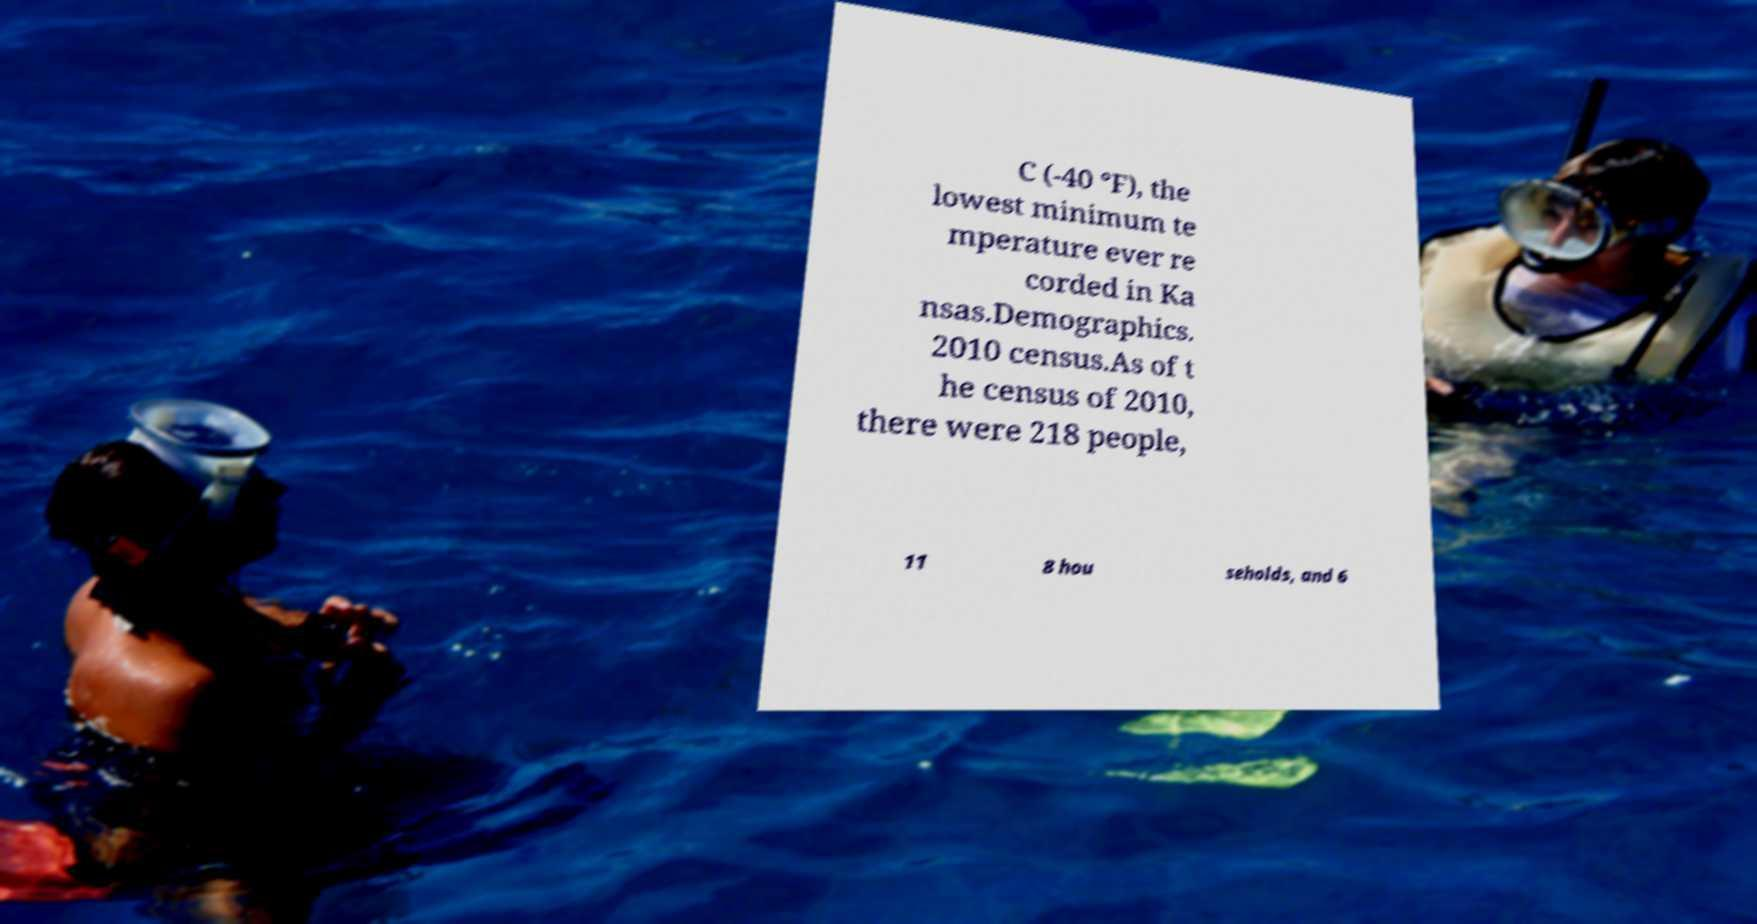Could you extract and type out the text from this image? C (-40 °F), the lowest minimum te mperature ever re corded in Ka nsas.Demographics. 2010 census.As of t he census of 2010, there were 218 people, 11 8 hou seholds, and 6 